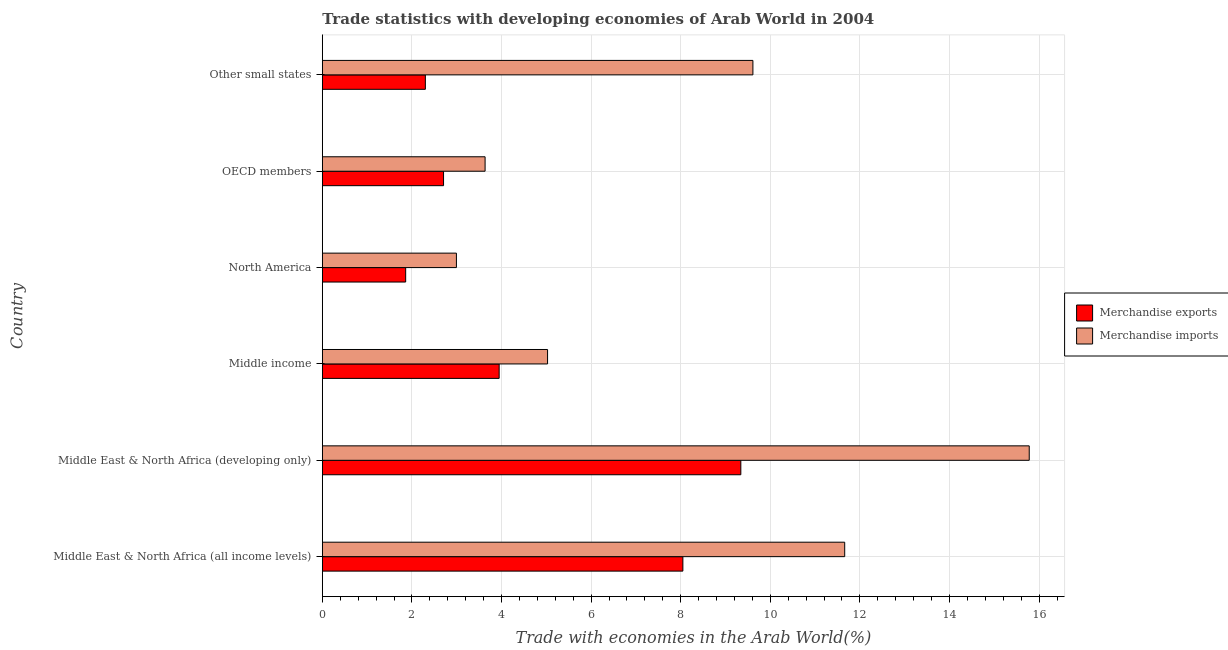How many different coloured bars are there?
Provide a succinct answer. 2. Are the number of bars on each tick of the Y-axis equal?
Your answer should be compact. Yes. How many bars are there on the 1st tick from the top?
Your answer should be compact. 2. What is the label of the 3rd group of bars from the top?
Offer a very short reply. North America. In how many cases, is the number of bars for a given country not equal to the number of legend labels?
Offer a terse response. 0. What is the merchandise imports in North America?
Provide a succinct answer. 2.99. Across all countries, what is the maximum merchandise exports?
Keep it short and to the point. 9.34. Across all countries, what is the minimum merchandise exports?
Your answer should be very brief. 1.86. In which country was the merchandise exports maximum?
Make the answer very short. Middle East & North Africa (developing only). What is the total merchandise imports in the graph?
Make the answer very short. 48.71. What is the difference between the merchandise exports in North America and that in Other small states?
Ensure brevity in your answer.  -0.44. What is the difference between the merchandise imports in Middle income and the merchandise exports in Other small states?
Make the answer very short. 2.73. What is the average merchandise exports per country?
Keep it short and to the point. 4.7. What is the difference between the merchandise imports and merchandise exports in Middle East & North Africa (developing only)?
Provide a succinct answer. 6.44. What is the ratio of the merchandise imports in OECD members to that in Other small states?
Provide a succinct answer. 0.38. Is the difference between the merchandise imports in Middle East & North Africa (all income levels) and Other small states greater than the difference between the merchandise exports in Middle East & North Africa (all income levels) and Other small states?
Your response must be concise. No. What is the difference between the highest and the second highest merchandise imports?
Ensure brevity in your answer.  4.12. What is the difference between the highest and the lowest merchandise exports?
Give a very brief answer. 7.48. In how many countries, is the merchandise exports greater than the average merchandise exports taken over all countries?
Provide a short and direct response. 2. What does the 1st bar from the top in OECD members represents?
Give a very brief answer. Merchandise imports. How many bars are there?
Give a very brief answer. 12. Are all the bars in the graph horizontal?
Offer a terse response. Yes. What is the difference between two consecutive major ticks on the X-axis?
Keep it short and to the point. 2. Are the values on the major ticks of X-axis written in scientific E-notation?
Your answer should be compact. No. Does the graph contain grids?
Your answer should be compact. Yes. Where does the legend appear in the graph?
Provide a short and direct response. Center right. How many legend labels are there?
Your answer should be very brief. 2. How are the legend labels stacked?
Your answer should be very brief. Vertical. What is the title of the graph?
Give a very brief answer. Trade statistics with developing economies of Arab World in 2004. What is the label or title of the X-axis?
Offer a terse response. Trade with economies in the Arab World(%). What is the label or title of the Y-axis?
Provide a succinct answer. Country. What is the Trade with economies in the Arab World(%) in Merchandise exports in Middle East & North Africa (all income levels)?
Provide a succinct answer. 8.05. What is the Trade with economies in the Arab World(%) of Merchandise imports in Middle East & North Africa (all income levels)?
Your answer should be very brief. 11.66. What is the Trade with economies in the Arab World(%) in Merchandise exports in Middle East & North Africa (developing only)?
Provide a short and direct response. 9.34. What is the Trade with economies in the Arab World(%) in Merchandise imports in Middle East & North Africa (developing only)?
Your answer should be very brief. 15.78. What is the Trade with economies in the Arab World(%) of Merchandise exports in Middle income?
Offer a terse response. 3.95. What is the Trade with economies in the Arab World(%) of Merchandise imports in Middle income?
Offer a terse response. 5.03. What is the Trade with economies in the Arab World(%) in Merchandise exports in North America?
Offer a terse response. 1.86. What is the Trade with economies in the Arab World(%) of Merchandise imports in North America?
Provide a short and direct response. 2.99. What is the Trade with economies in the Arab World(%) in Merchandise exports in OECD members?
Offer a terse response. 2.71. What is the Trade with economies in the Arab World(%) of Merchandise imports in OECD members?
Your answer should be compact. 3.63. What is the Trade with economies in the Arab World(%) of Merchandise exports in Other small states?
Your answer should be very brief. 2.3. What is the Trade with economies in the Arab World(%) in Merchandise imports in Other small states?
Provide a short and direct response. 9.61. Across all countries, what is the maximum Trade with economies in the Arab World(%) of Merchandise exports?
Give a very brief answer. 9.34. Across all countries, what is the maximum Trade with economies in the Arab World(%) in Merchandise imports?
Provide a succinct answer. 15.78. Across all countries, what is the minimum Trade with economies in the Arab World(%) in Merchandise exports?
Provide a short and direct response. 1.86. Across all countries, what is the minimum Trade with economies in the Arab World(%) in Merchandise imports?
Your answer should be compact. 2.99. What is the total Trade with economies in the Arab World(%) in Merchandise exports in the graph?
Offer a very short reply. 28.2. What is the total Trade with economies in the Arab World(%) of Merchandise imports in the graph?
Give a very brief answer. 48.71. What is the difference between the Trade with economies in the Arab World(%) of Merchandise exports in Middle East & North Africa (all income levels) and that in Middle East & North Africa (developing only)?
Your response must be concise. -1.29. What is the difference between the Trade with economies in the Arab World(%) of Merchandise imports in Middle East & North Africa (all income levels) and that in Middle East & North Africa (developing only)?
Your answer should be compact. -4.12. What is the difference between the Trade with economies in the Arab World(%) of Merchandise exports in Middle East & North Africa (all income levels) and that in Middle income?
Offer a terse response. 4.1. What is the difference between the Trade with economies in the Arab World(%) of Merchandise imports in Middle East & North Africa (all income levels) and that in Middle income?
Your answer should be very brief. 6.63. What is the difference between the Trade with economies in the Arab World(%) in Merchandise exports in Middle East & North Africa (all income levels) and that in North America?
Your answer should be very brief. 6.19. What is the difference between the Trade with economies in the Arab World(%) in Merchandise imports in Middle East & North Africa (all income levels) and that in North America?
Provide a succinct answer. 8.67. What is the difference between the Trade with economies in the Arab World(%) of Merchandise exports in Middle East & North Africa (all income levels) and that in OECD members?
Your answer should be compact. 5.34. What is the difference between the Trade with economies in the Arab World(%) of Merchandise imports in Middle East & North Africa (all income levels) and that in OECD members?
Give a very brief answer. 8.03. What is the difference between the Trade with economies in the Arab World(%) in Merchandise exports in Middle East & North Africa (all income levels) and that in Other small states?
Offer a very short reply. 5.75. What is the difference between the Trade with economies in the Arab World(%) of Merchandise imports in Middle East & North Africa (all income levels) and that in Other small states?
Provide a succinct answer. 2.05. What is the difference between the Trade with economies in the Arab World(%) of Merchandise exports in Middle East & North Africa (developing only) and that in Middle income?
Make the answer very short. 5.39. What is the difference between the Trade with economies in the Arab World(%) in Merchandise imports in Middle East & North Africa (developing only) and that in Middle income?
Offer a terse response. 10.75. What is the difference between the Trade with economies in the Arab World(%) of Merchandise exports in Middle East & North Africa (developing only) and that in North America?
Provide a short and direct response. 7.48. What is the difference between the Trade with economies in the Arab World(%) of Merchandise imports in Middle East & North Africa (developing only) and that in North America?
Provide a succinct answer. 12.79. What is the difference between the Trade with economies in the Arab World(%) of Merchandise exports in Middle East & North Africa (developing only) and that in OECD members?
Your answer should be very brief. 6.64. What is the difference between the Trade with economies in the Arab World(%) of Merchandise imports in Middle East & North Africa (developing only) and that in OECD members?
Your answer should be compact. 12.15. What is the difference between the Trade with economies in the Arab World(%) in Merchandise exports in Middle East & North Africa (developing only) and that in Other small states?
Make the answer very short. 7.04. What is the difference between the Trade with economies in the Arab World(%) of Merchandise imports in Middle East & North Africa (developing only) and that in Other small states?
Keep it short and to the point. 6.17. What is the difference between the Trade with economies in the Arab World(%) in Merchandise exports in Middle income and that in North America?
Make the answer very short. 2.09. What is the difference between the Trade with economies in the Arab World(%) of Merchandise imports in Middle income and that in North America?
Provide a succinct answer. 2.03. What is the difference between the Trade with economies in the Arab World(%) in Merchandise exports in Middle income and that in OECD members?
Your answer should be compact. 1.24. What is the difference between the Trade with economies in the Arab World(%) in Merchandise imports in Middle income and that in OECD members?
Offer a terse response. 1.39. What is the difference between the Trade with economies in the Arab World(%) in Merchandise exports in Middle income and that in Other small states?
Give a very brief answer. 1.65. What is the difference between the Trade with economies in the Arab World(%) in Merchandise imports in Middle income and that in Other small states?
Make the answer very short. -4.58. What is the difference between the Trade with economies in the Arab World(%) in Merchandise exports in North America and that in OECD members?
Your answer should be compact. -0.85. What is the difference between the Trade with economies in the Arab World(%) of Merchandise imports in North America and that in OECD members?
Offer a very short reply. -0.64. What is the difference between the Trade with economies in the Arab World(%) of Merchandise exports in North America and that in Other small states?
Your response must be concise. -0.44. What is the difference between the Trade with economies in the Arab World(%) of Merchandise imports in North America and that in Other small states?
Ensure brevity in your answer.  -6.62. What is the difference between the Trade with economies in the Arab World(%) in Merchandise exports in OECD members and that in Other small states?
Provide a short and direct response. 0.41. What is the difference between the Trade with economies in the Arab World(%) in Merchandise imports in OECD members and that in Other small states?
Make the answer very short. -5.98. What is the difference between the Trade with economies in the Arab World(%) in Merchandise exports in Middle East & North Africa (all income levels) and the Trade with economies in the Arab World(%) in Merchandise imports in Middle East & North Africa (developing only)?
Give a very brief answer. -7.73. What is the difference between the Trade with economies in the Arab World(%) in Merchandise exports in Middle East & North Africa (all income levels) and the Trade with economies in the Arab World(%) in Merchandise imports in Middle income?
Keep it short and to the point. 3.02. What is the difference between the Trade with economies in the Arab World(%) in Merchandise exports in Middle East & North Africa (all income levels) and the Trade with economies in the Arab World(%) in Merchandise imports in North America?
Make the answer very short. 5.06. What is the difference between the Trade with economies in the Arab World(%) in Merchandise exports in Middle East & North Africa (all income levels) and the Trade with economies in the Arab World(%) in Merchandise imports in OECD members?
Provide a succinct answer. 4.42. What is the difference between the Trade with economies in the Arab World(%) of Merchandise exports in Middle East & North Africa (all income levels) and the Trade with economies in the Arab World(%) of Merchandise imports in Other small states?
Your answer should be compact. -1.56. What is the difference between the Trade with economies in the Arab World(%) in Merchandise exports in Middle East & North Africa (developing only) and the Trade with economies in the Arab World(%) in Merchandise imports in Middle income?
Offer a very short reply. 4.31. What is the difference between the Trade with economies in the Arab World(%) in Merchandise exports in Middle East & North Africa (developing only) and the Trade with economies in the Arab World(%) in Merchandise imports in North America?
Make the answer very short. 6.35. What is the difference between the Trade with economies in the Arab World(%) in Merchandise exports in Middle East & North Africa (developing only) and the Trade with economies in the Arab World(%) in Merchandise imports in OECD members?
Offer a very short reply. 5.71. What is the difference between the Trade with economies in the Arab World(%) in Merchandise exports in Middle East & North Africa (developing only) and the Trade with economies in the Arab World(%) in Merchandise imports in Other small states?
Keep it short and to the point. -0.27. What is the difference between the Trade with economies in the Arab World(%) in Merchandise exports in Middle income and the Trade with economies in the Arab World(%) in Merchandise imports in North America?
Your answer should be compact. 0.95. What is the difference between the Trade with economies in the Arab World(%) in Merchandise exports in Middle income and the Trade with economies in the Arab World(%) in Merchandise imports in OECD members?
Ensure brevity in your answer.  0.31. What is the difference between the Trade with economies in the Arab World(%) in Merchandise exports in Middle income and the Trade with economies in the Arab World(%) in Merchandise imports in Other small states?
Make the answer very short. -5.66. What is the difference between the Trade with economies in the Arab World(%) of Merchandise exports in North America and the Trade with economies in the Arab World(%) of Merchandise imports in OECD members?
Give a very brief answer. -1.77. What is the difference between the Trade with economies in the Arab World(%) in Merchandise exports in North America and the Trade with economies in the Arab World(%) in Merchandise imports in Other small states?
Make the answer very short. -7.75. What is the difference between the Trade with economies in the Arab World(%) in Merchandise exports in OECD members and the Trade with economies in the Arab World(%) in Merchandise imports in Other small states?
Provide a succinct answer. -6.91. What is the average Trade with economies in the Arab World(%) in Merchandise exports per country?
Your response must be concise. 4.7. What is the average Trade with economies in the Arab World(%) of Merchandise imports per country?
Give a very brief answer. 8.12. What is the difference between the Trade with economies in the Arab World(%) in Merchandise exports and Trade with economies in the Arab World(%) in Merchandise imports in Middle East & North Africa (all income levels)?
Keep it short and to the point. -3.61. What is the difference between the Trade with economies in the Arab World(%) of Merchandise exports and Trade with economies in the Arab World(%) of Merchandise imports in Middle East & North Africa (developing only)?
Offer a very short reply. -6.44. What is the difference between the Trade with economies in the Arab World(%) of Merchandise exports and Trade with economies in the Arab World(%) of Merchandise imports in Middle income?
Provide a short and direct response. -1.08. What is the difference between the Trade with economies in the Arab World(%) in Merchandise exports and Trade with economies in the Arab World(%) in Merchandise imports in North America?
Give a very brief answer. -1.13. What is the difference between the Trade with economies in the Arab World(%) in Merchandise exports and Trade with economies in the Arab World(%) in Merchandise imports in OECD members?
Ensure brevity in your answer.  -0.93. What is the difference between the Trade with economies in the Arab World(%) in Merchandise exports and Trade with economies in the Arab World(%) in Merchandise imports in Other small states?
Keep it short and to the point. -7.31. What is the ratio of the Trade with economies in the Arab World(%) in Merchandise exports in Middle East & North Africa (all income levels) to that in Middle East & North Africa (developing only)?
Your answer should be very brief. 0.86. What is the ratio of the Trade with economies in the Arab World(%) of Merchandise imports in Middle East & North Africa (all income levels) to that in Middle East & North Africa (developing only)?
Give a very brief answer. 0.74. What is the ratio of the Trade with economies in the Arab World(%) of Merchandise exports in Middle East & North Africa (all income levels) to that in Middle income?
Keep it short and to the point. 2.04. What is the ratio of the Trade with economies in the Arab World(%) of Merchandise imports in Middle East & North Africa (all income levels) to that in Middle income?
Give a very brief answer. 2.32. What is the ratio of the Trade with economies in the Arab World(%) of Merchandise exports in Middle East & North Africa (all income levels) to that in North America?
Give a very brief answer. 4.33. What is the ratio of the Trade with economies in the Arab World(%) of Merchandise imports in Middle East & North Africa (all income levels) to that in North America?
Offer a terse response. 3.9. What is the ratio of the Trade with economies in the Arab World(%) in Merchandise exports in Middle East & North Africa (all income levels) to that in OECD members?
Your answer should be compact. 2.97. What is the ratio of the Trade with economies in the Arab World(%) of Merchandise imports in Middle East & North Africa (all income levels) to that in OECD members?
Offer a terse response. 3.21. What is the ratio of the Trade with economies in the Arab World(%) of Merchandise exports in Middle East & North Africa (all income levels) to that in Other small states?
Provide a short and direct response. 3.5. What is the ratio of the Trade with economies in the Arab World(%) of Merchandise imports in Middle East & North Africa (all income levels) to that in Other small states?
Your answer should be very brief. 1.21. What is the ratio of the Trade with economies in the Arab World(%) in Merchandise exports in Middle East & North Africa (developing only) to that in Middle income?
Make the answer very short. 2.37. What is the ratio of the Trade with economies in the Arab World(%) in Merchandise imports in Middle East & North Africa (developing only) to that in Middle income?
Offer a terse response. 3.14. What is the ratio of the Trade with economies in the Arab World(%) of Merchandise exports in Middle East & North Africa (developing only) to that in North America?
Give a very brief answer. 5.02. What is the ratio of the Trade with economies in the Arab World(%) in Merchandise imports in Middle East & North Africa (developing only) to that in North America?
Your answer should be compact. 5.27. What is the ratio of the Trade with economies in the Arab World(%) of Merchandise exports in Middle East & North Africa (developing only) to that in OECD members?
Keep it short and to the point. 3.45. What is the ratio of the Trade with economies in the Arab World(%) in Merchandise imports in Middle East & North Africa (developing only) to that in OECD members?
Offer a terse response. 4.34. What is the ratio of the Trade with economies in the Arab World(%) of Merchandise exports in Middle East & North Africa (developing only) to that in Other small states?
Your answer should be compact. 4.06. What is the ratio of the Trade with economies in the Arab World(%) of Merchandise imports in Middle East & North Africa (developing only) to that in Other small states?
Ensure brevity in your answer.  1.64. What is the ratio of the Trade with economies in the Arab World(%) of Merchandise exports in Middle income to that in North America?
Provide a succinct answer. 2.12. What is the ratio of the Trade with economies in the Arab World(%) in Merchandise imports in Middle income to that in North America?
Ensure brevity in your answer.  1.68. What is the ratio of the Trade with economies in the Arab World(%) of Merchandise exports in Middle income to that in OECD members?
Your response must be concise. 1.46. What is the ratio of the Trade with economies in the Arab World(%) in Merchandise imports in Middle income to that in OECD members?
Keep it short and to the point. 1.38. What is the ratio of the Trade with economies in the Arab World(%) of Merchandise exports in Middle income to that in Other small states?
Give a very brief answer. 1.72. What is the ratio of the Trade with economies in the Arab World(%) of Merchandise imports in Middle income to that in Other small states?
Offer a very short reply. 0.52. What is the ratio of the Trade with economies in the Arab World(%) of Merchandise exports in North America to that in OECD members?
Keep it short and to the point. 0.69. What is the ratio of the Trade with economies in the Arab World(%) of Merchandise imports in North America to that in OECD members?
Offer a very short reply. 0.82. What is the ratio of the Trade with economies in the Arab World(%) of Merchandise exports in North America to that in Other small states?
Give a very brief answer. 0.81. What is the ratio of the Trade with economies in the Arab World(%) of Merchandise imports in North America to that in Other small states?
Offer a terse response. 0.31. What is the ratio of the Trade with economies in the Arab World(%) in Merchandise exports in OECD members to that in Other small states?
Make the answer very short. 1.18. What is the ratio of the Trade with economies in the Arab World(%) in Merchandise imports in OECD members to that in Other small states?
Your answer should be compact. 0.38. What is the difference between the highest and the second highest Trade with economies in the Arab World(%) in Merchandise exports?
Keep it short and to the point. 1.29. What is the difference between the highest and the second highest Trade with economies in the Arab World(%) in Merchandise imports?
Your answer should be compact. 4.12. What is the difference between the highest and the lowest Trade with economies in the Arab World(%) in Merchandise exports?
Your answer should be compact. 7.48. What is the difference between the highest and the lowest Trade with economies in the Arab World(%) in Merchandise imports?
Your answer should be compact. 12.79. 